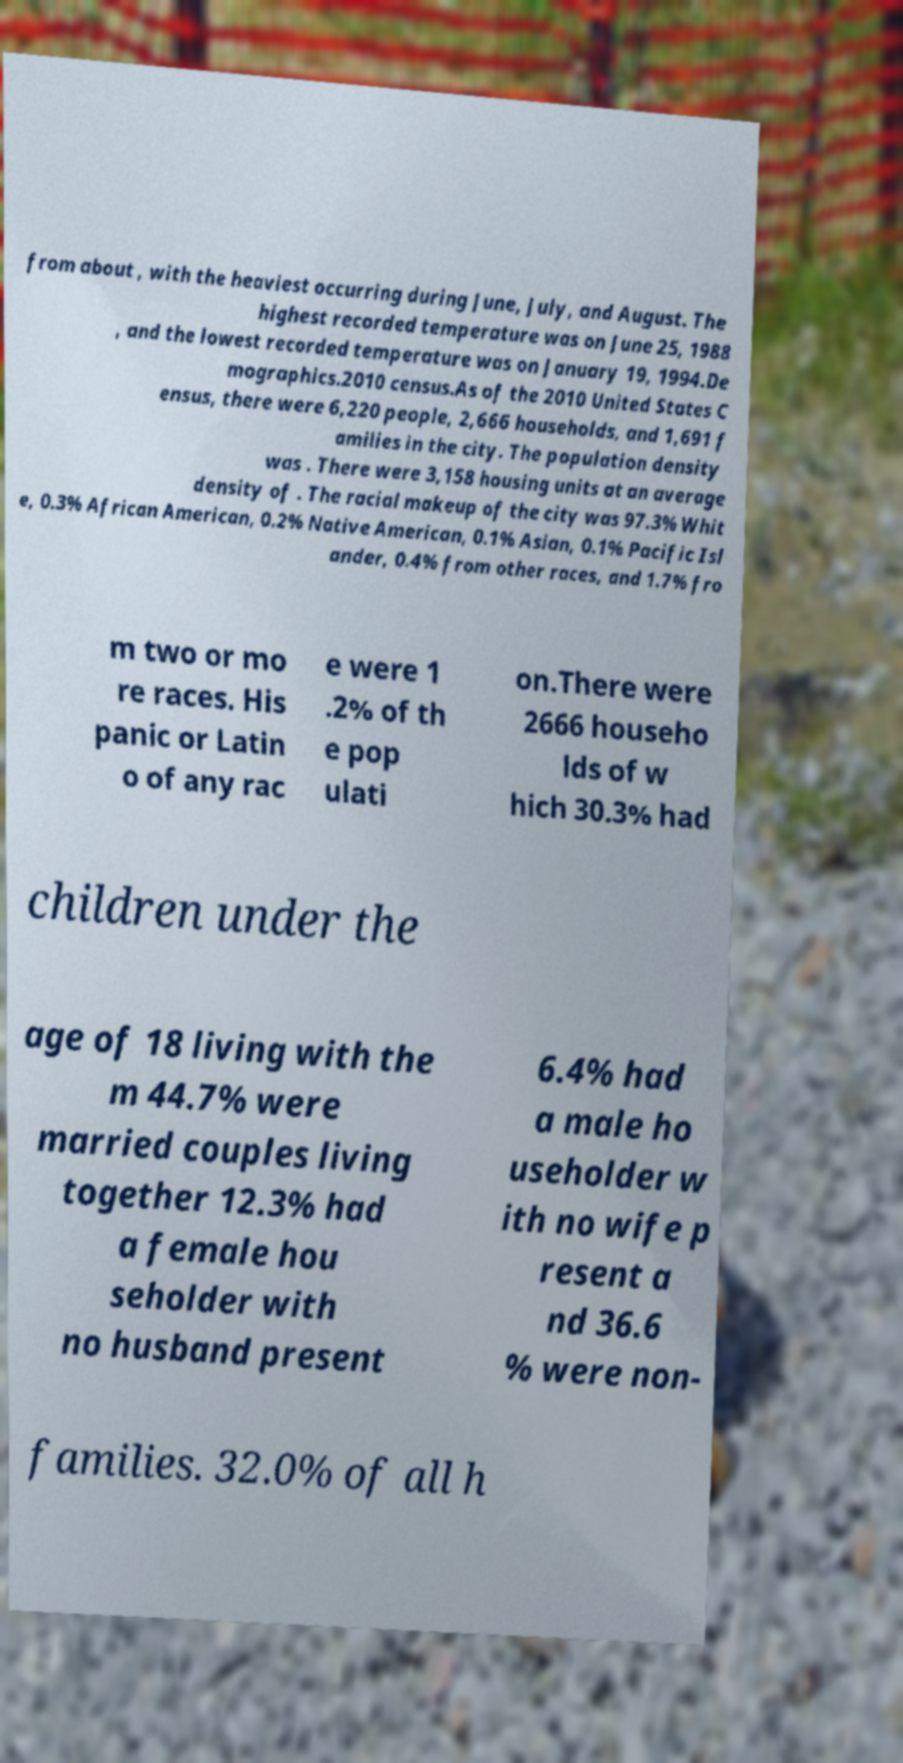Can you accurately transcribe the text from the provided image for me? from about , with the heaviest occurring during June, July, and August. The highest recorded temperature was on June 25, 1988 , and the lowest recorded temperature was on January 19, 1994.De mographics.2010 census.As of the 2010 United States C ensus, there were 6,220 people, 2,666 households, and 1,691 f amilies in the city. The population density was . There were 3,158 housing units at an average density of . The racial makeup of the city was 97.3% Whit e, 0.3% African American, 0.2% Native American, 0.1% Asian, 0.1% Pacific Isl ander, 0.4% from other races, and 1.7% fro m two or mo re races. His panic or Latin o of any rac e were 1 .2% of th e pop ulati on.There were 2666 househo lds of w hich 30.3% had children under the age of 18 living with the m 44.7% were married couples living together 12.3% had a female hou seholder with no husband present 6.4% had a male ho useholder w ith no wife p resent a nd 36.6 % were non- families. 32.0% of all h 